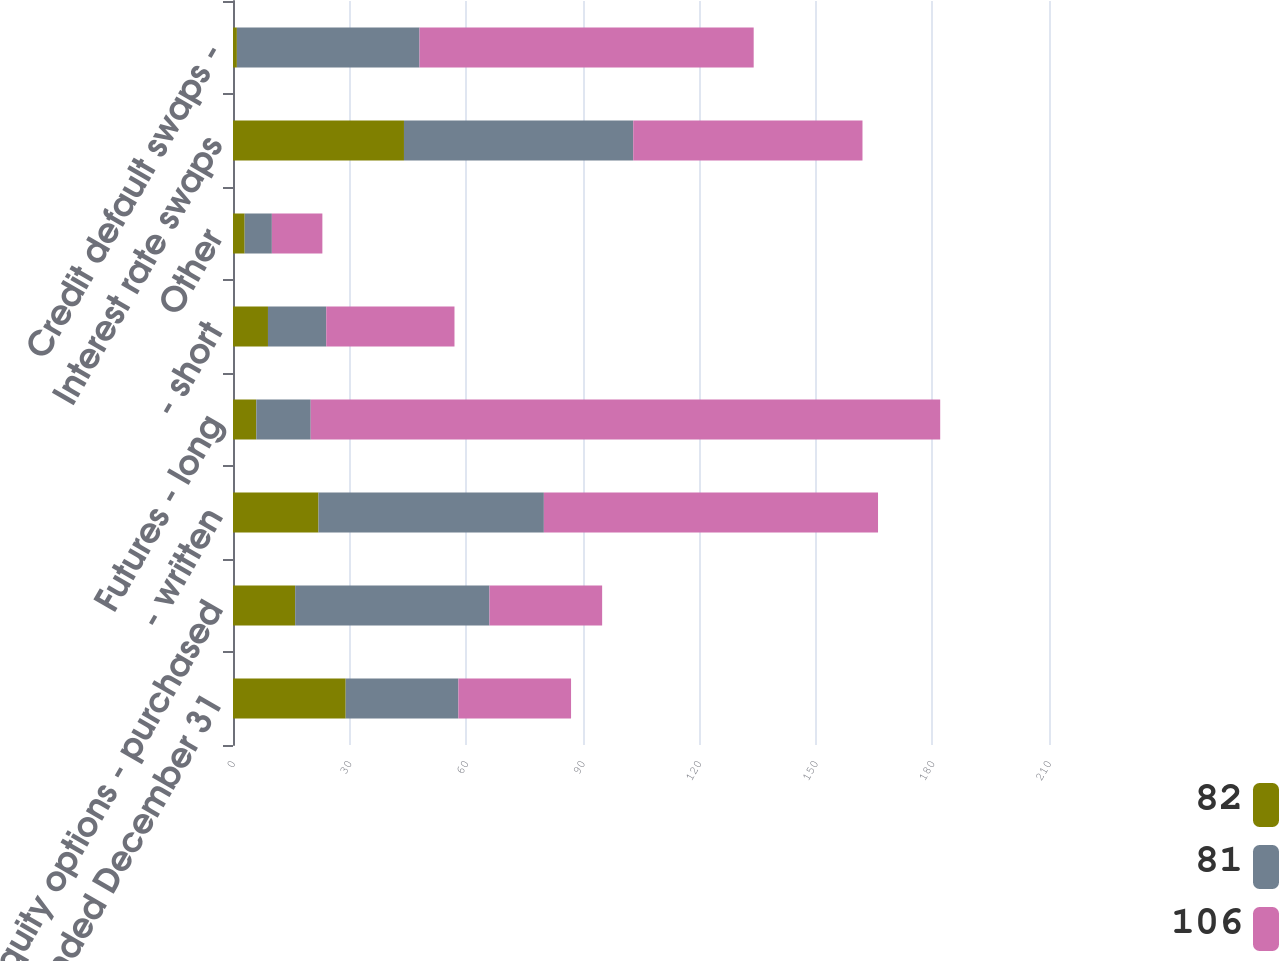Convert chart. <chart><loc_0><loc_0><loc_500><loc_500><stacked_bar_chart><ecel><fcel>Year Ended December 31<fcel>Equity options - purchased<fcel>- written<fcel>Futures - long<fcel>- short<fcel>Other<fcel>Interest rate swaps<fcel>Credit default swaps -<nl><fcel>82<fcel>29<fcel>16<fcel>22<fcel>6<fcel>9<fcel>3<fcel>44<fcel>1<nl><fcel>81<fcel>29<fcel>50<fcel>58<fcel>14<fcel>15<fcel>7<fcel>59<fcel>47<nl><fcel>106<fcel>29<fcel>29<fcel>86<fcel>162<fcel>33<fcel>13<fcel>59<fcel>86<nl></chart> 